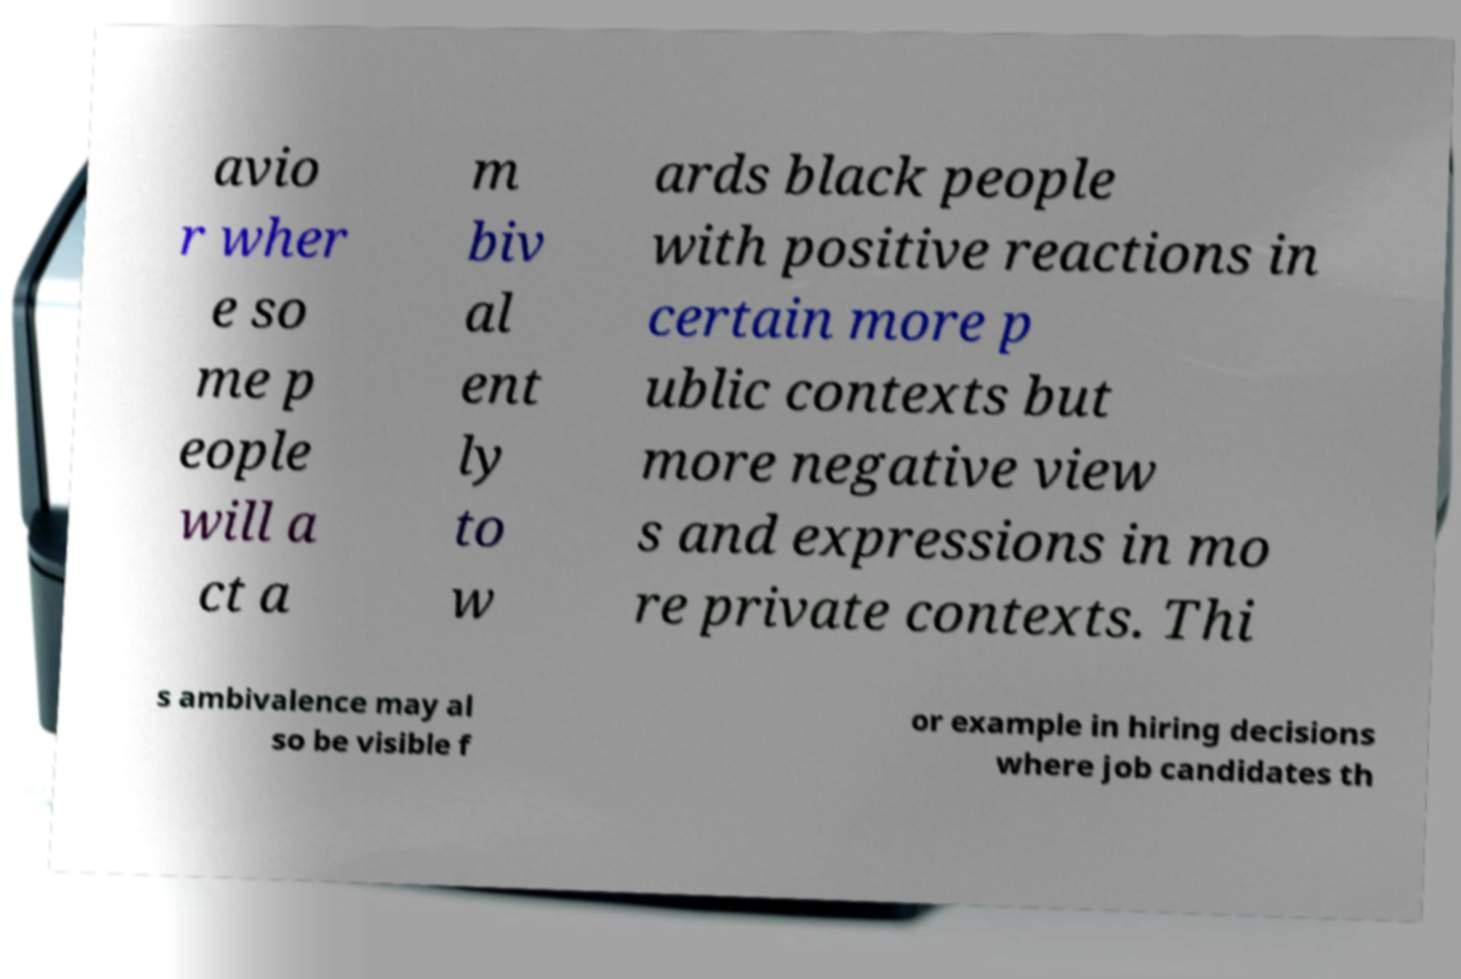I need the written content from this picture converted into text. Can you do that? avio r wher e so me p eople will a ct a m biv al ent ly to w ards black people with positive reactions in certain more p ublic contexts but more negative view s and expressions in mo re private contexts. Thi s ambivalence may al so be visible f or example in hiring decisions where job candidates th 